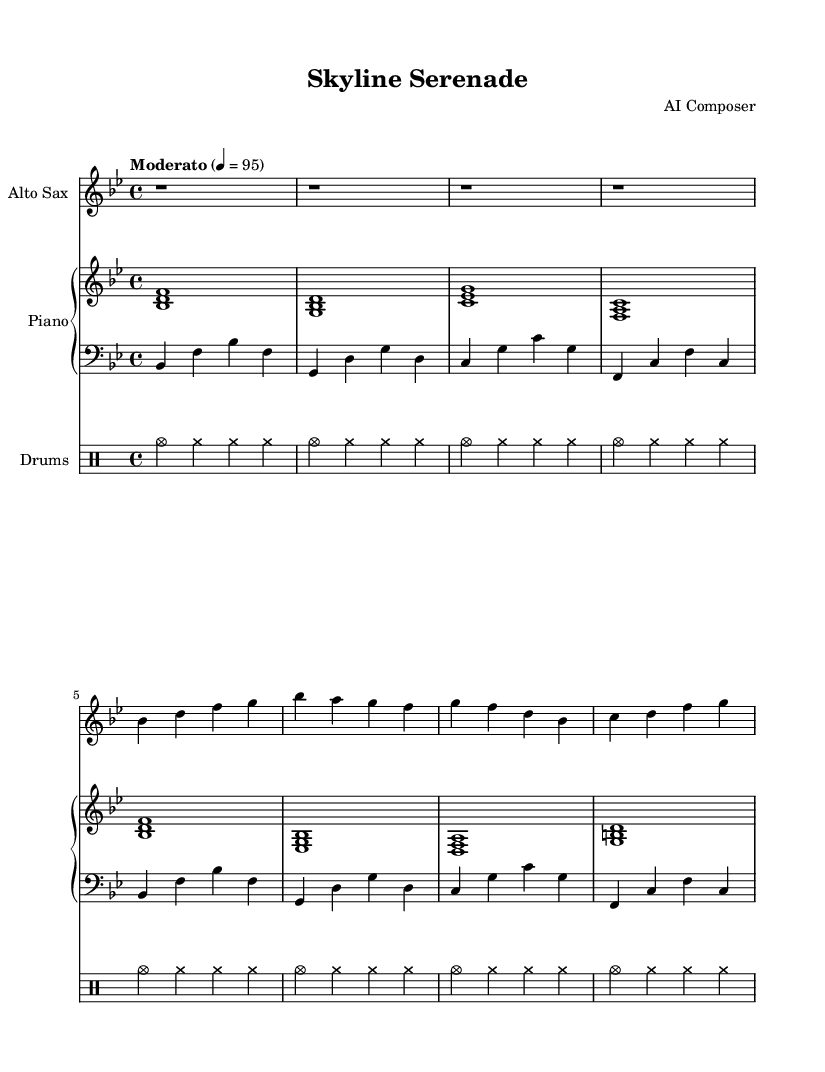What is the key signature of this music? The key signature is indicated at the beginning of the staff with two flats, which corresponds to B flat major.
Answer: B flat major What is the time signature of this piece? The time signature is shown at the beginning of the staff and is indicated as 4/4, meaning there are four beats per measure.
Answer: 4/4 What is the tempo marking for this composition? The tempo marking is indicated as "Moderato" and a metronome marking of 4 = 95, which guides the speed of the piece.
Answer: Moderato, 4 = 95 How many measures are in the saxophone part? By counting the distinct measures indicated in the saxophone part, we see there are a total of 8 measures present.
Answer: 8 What instruments are included in this score? The score indicates the inclusion of an Alto Saxophone, Piano, Bass, and Drums, collectively contributing to the arrangement.
Answer: Alto Saxophone, Piano, Bass, Drums How is the piano part structured in terms of staves? The piano part is composed of two staves: one for the right hand (treble) and one for the left hand (bass), typically used for a complete piano accompaniment.
Answer: Two staves What rhythmic pattern do the drums follow? The drum part employs a repeated rhythmic pattern of cymbals, indicated within a repetitive structure which signifies there's consistency in the accompaniment.
Answer: Cymbal rhythm pattern 